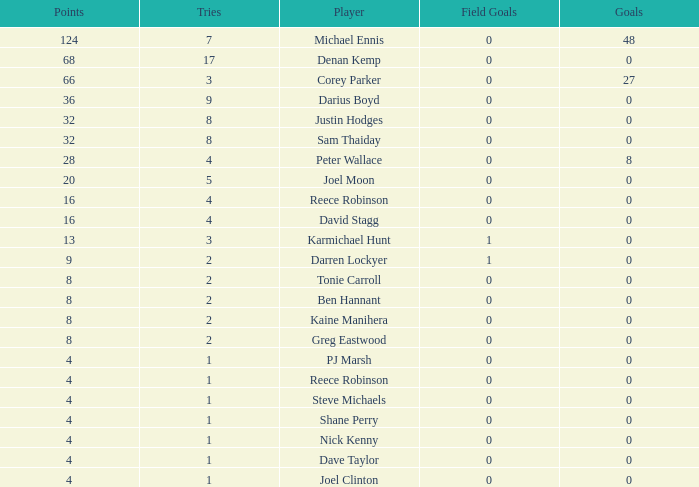What is the total number of field goals of Denan Kemp, who has more than 4 tries, more than 32 points, and 0 goals? 1.0. 